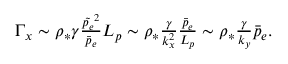<formula> <loc_0><loc_0><loc_500><loc_500>\begin{array} { r } { \Gamma _ { x } \sim \rho _ { * } \gamma \frac { \tilde { p _ { e } } ^ { 2 } } { \bar { p } _ { e } } L _ { p } \sim \rho _ { * } \frac { \gamma } { k _ { x } ^ { 2 } } \frac { \bar { p } _ { e } } { L _ { p } } \sim \rho _ { * } \frac { \gamma } { k _ { y } } \bar { p } _ { e } . } \end{array}</formula> 